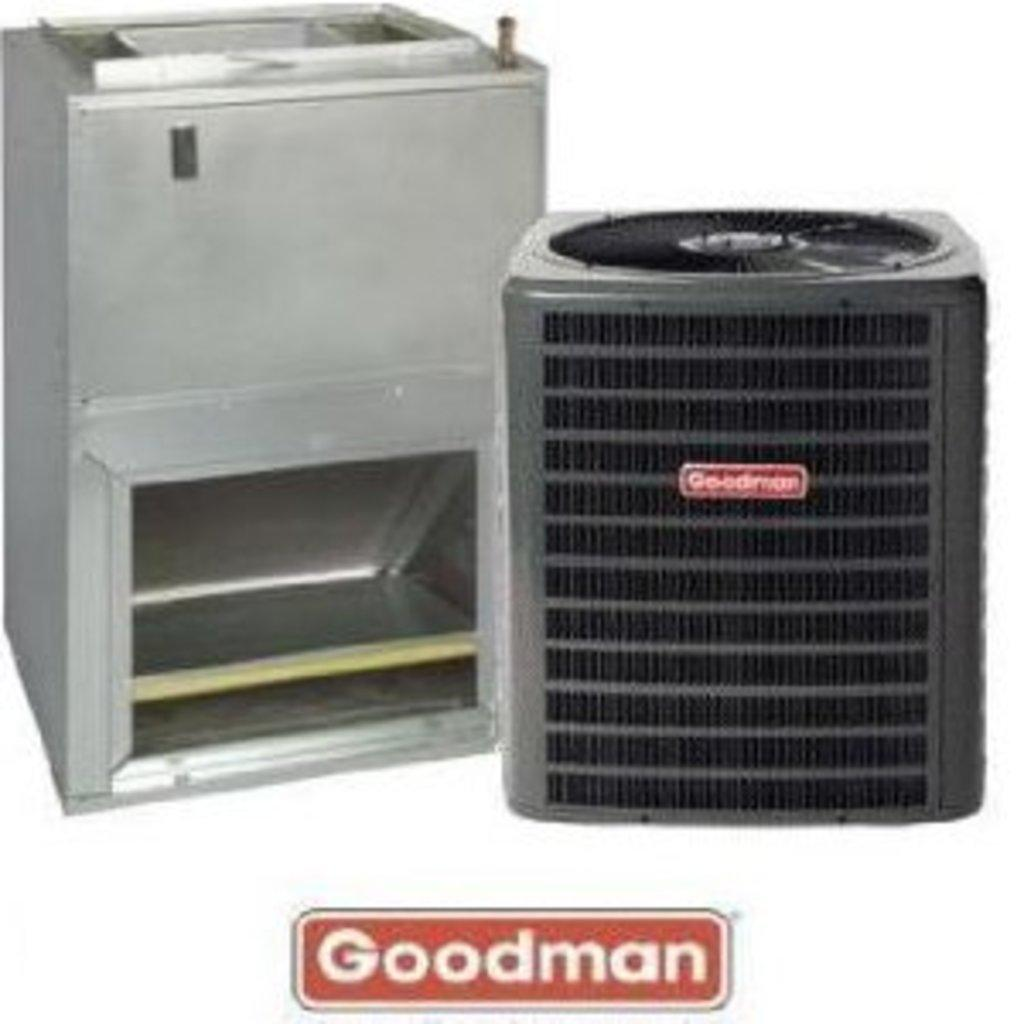<image>
Provide a brief description of the given image. an air vent system with filter and duct detail for Goodman 